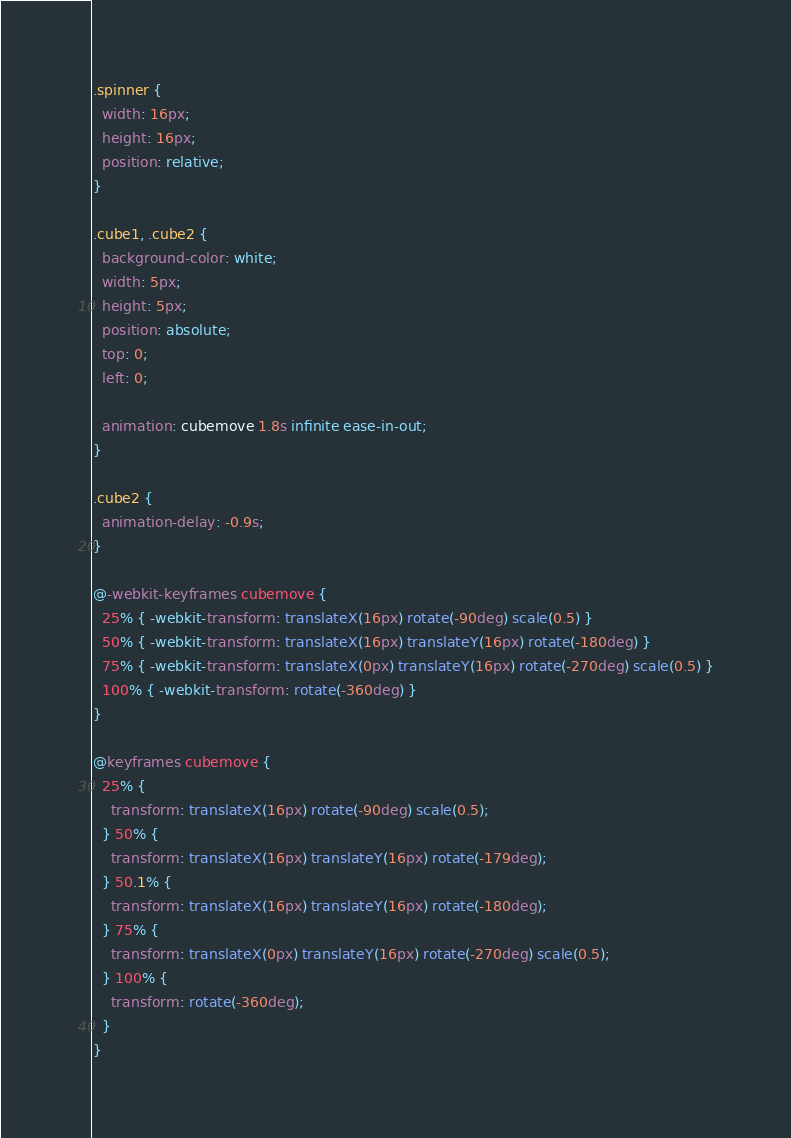<code> <loc_0><loc_0><loc_500><loc_500><_CSS_>.spinner {
  width: 16px;
  height: 16px;
  position: relative;
}

.cube1, .cube2 {
  background-color: white;
  width: 5px;
  height: 5px;
  position: absolute;
  top: 0;
  left: 0;

  animation: cubemove 1.8s infinite ease-in-out;
}

.cube2 {
  animation-delay: -0.9s;
}

@-webkit-keyframes cubemove {
  25% { -webkit-transform: translateX(16px) rotate(-90deg) scale(0.5) }
  50% { -webkit-transform: translateX(16px) translateY(16px) rotate(-180deg) }
  75% { -webkit-transform: translateX(0px) translateY(16px) rotate(-270deg) scale(0.5) }
  100% { -webkit-transform: rotate(-360deg) }
}

@keyframes cubemove {
  25% {
    transform: translateX(16px) rotate(-90deg) scale(0.5);
  } 50% {
    transform: translateX(16px) translateY(16px) rotate(-179deg);
  } 50.1% {
    transform: translateX(16px) translateY(16px) rotate(-180deg);
  } 75% {
    transform: translateX(0px) translateY(16px) rotate(-270deg) scale(0.5);
  } 100% {
    transform: rotate(-360deg);
  }
}
</code> 